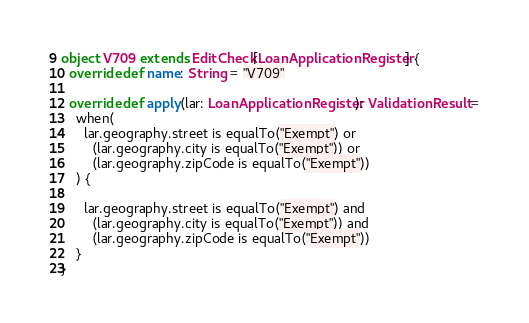Convert code to text. <code><loc_0><loc_0><loc_500><loc_500><_Scala_>object V709 extends EditCheck[LoanApplicationRegister] {
  override def name: String = "V709"

  override def apply(lar: LoanApplicationRegister): ValidationResult =
    when(
      lar.geography.street is equalTo("Exempt") or
        (lar.geography.city is equalTo("Exempt")) or
        (lar.geography.zipCode is equalTo("Exempt"))
    ) {

      lar.geography.street is equalTo("Exempt") and
        (lar.geography.city is equalTo("Exempt")) and
        (lar.geography.zipCode is equalTo("Exempt"))
    }
}
</code> 